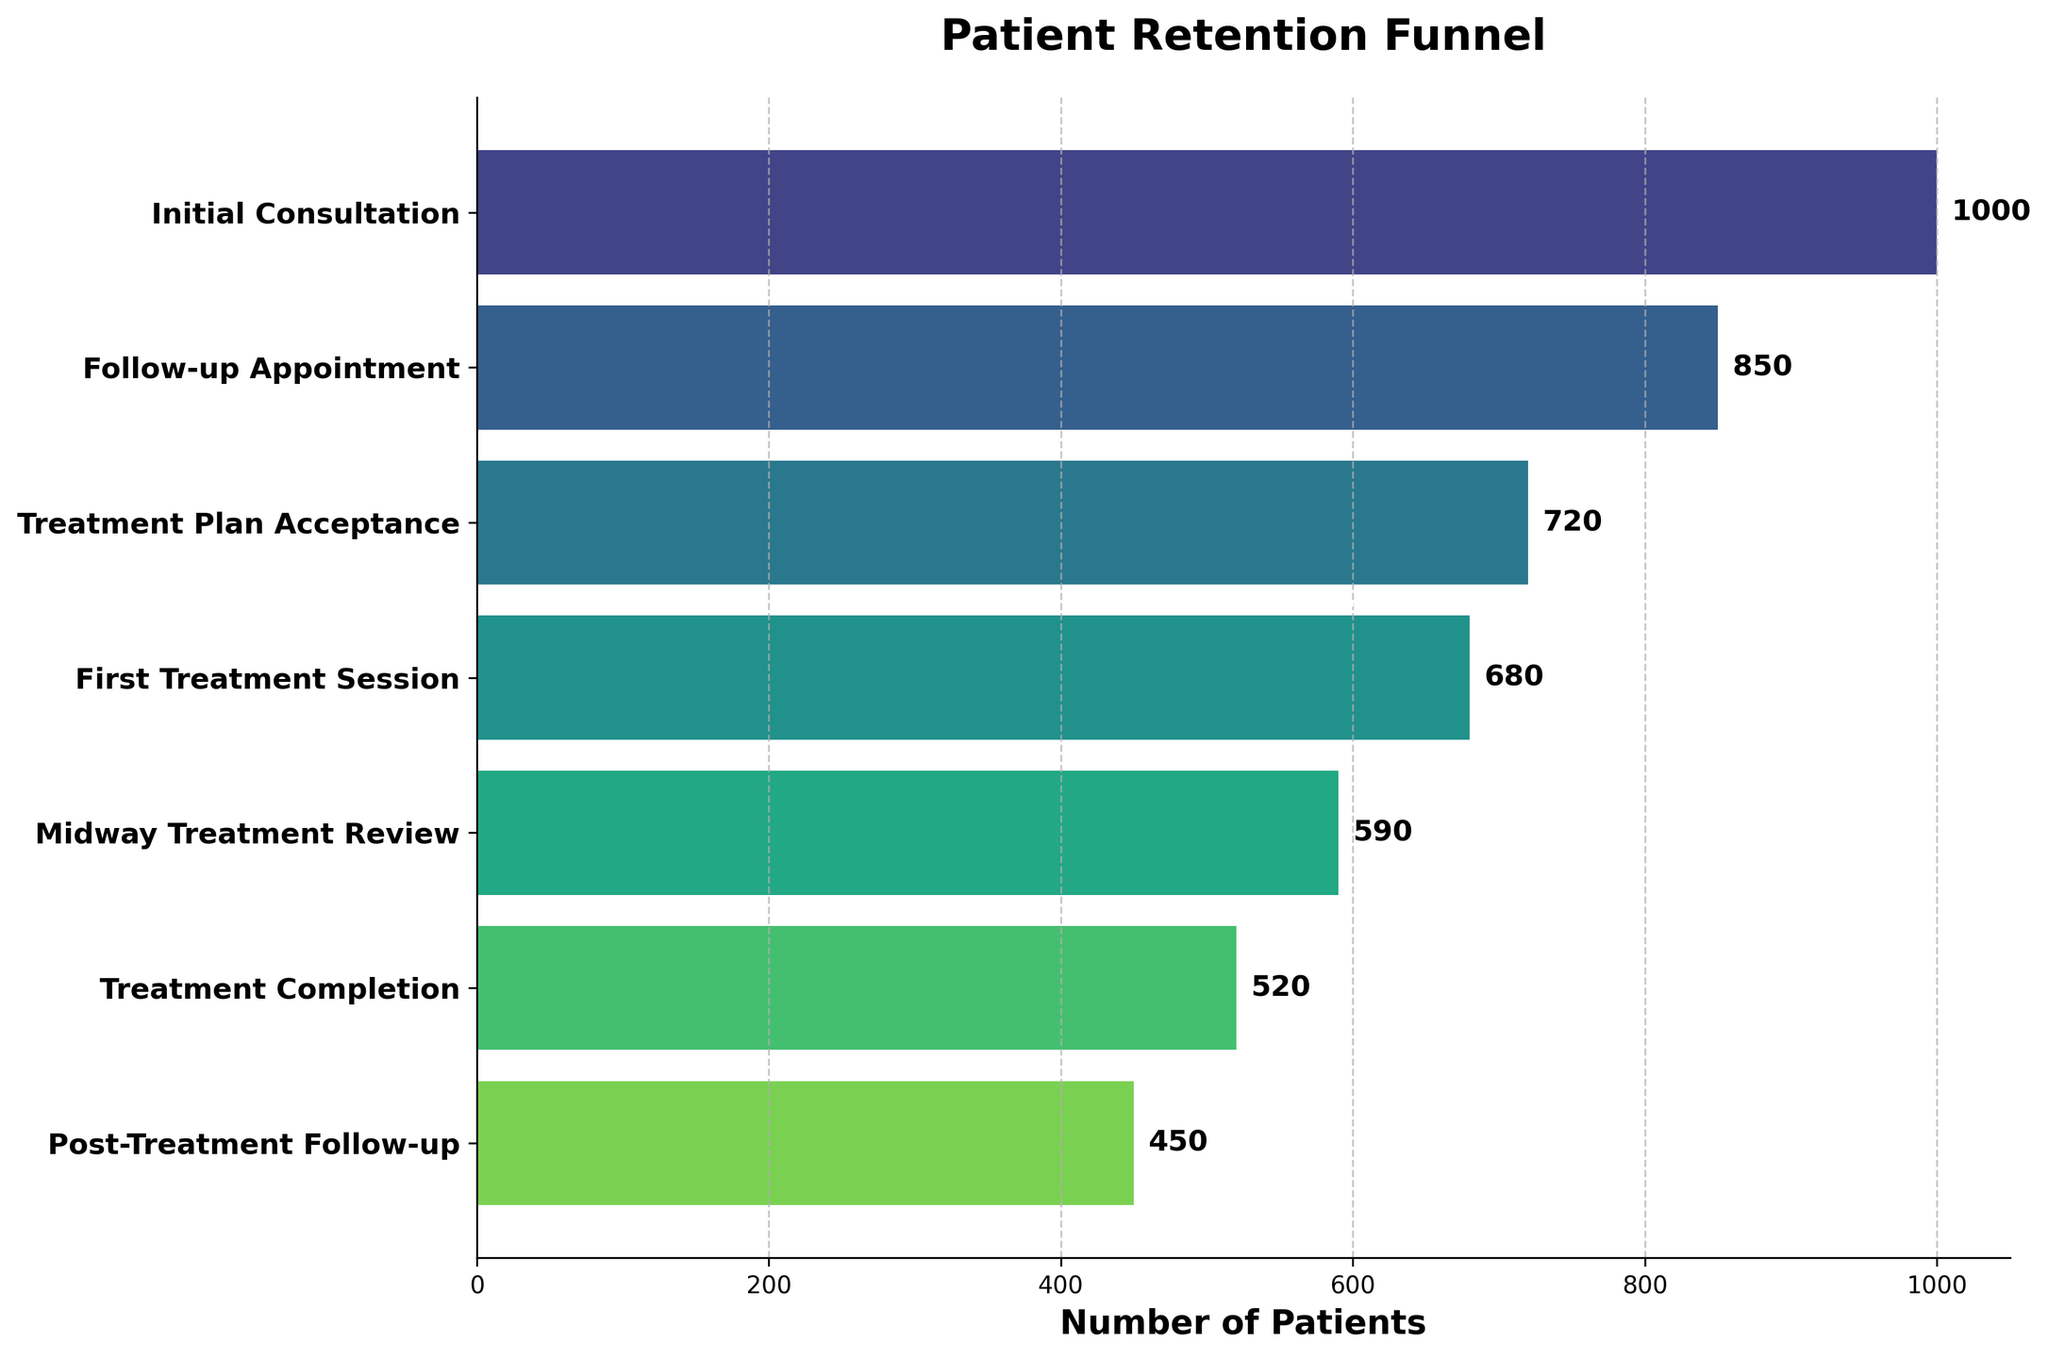What is the title of the chart? The title is written above the chart and summarizes the contents of the chart.
Answer: Patient Retention Funnel How many stages are there in the funnel? Count the number of stages listed on the Y-axis of the chart.
Answer: 7 At which stage is patient dropout the highest? Identify the stage with the largest difference in the number of patients compared to the previous stage.
Answer: Follow-up Appointment to Treatment Plan Acceptance How many patients completed the first treatment session? Read the number next to "First Treatment Session" on the horizontal bars.
Answer: 680 What percentage of patients moved from the initial consultation to the post-treatment follow-up? Calculate the percentage by dividing the number of patients at the post-treatment follow-up by the initial consultation and multiplying by 100. (450 / 1000) * 100 = 45%
Answer: 45% What is the difference in patient numbers between the follow-up appointment and the treatment plan acceptance stages? Subtract the number of patients in the treatment plan acceptance from the number in the follow-up appointment stage. 850 - 720 = 130
Answer: 130 Which stage has the lowest patient retention, and what is the retention percentage? Identify the stage with the smallest number of patients retained and calculate its percentage compared to the previous stage. The lowest retention is from the Follow-up Appointment to Treatment Plan Acceptance, (720 / 850) * 100 = 84.7%.
Answer: Treatment Plan Acceptance, 84.7% What is the total number of patients who dropped out from the initial consultation to the treatment completion stage? Subtract the number of patients at the treatment completion from the initial consultation. 1000 - 520 = 480
Answer: 480 What percentage of patients attended the midway treatment review after the first treatment session? Calculate the percentage by dividing the number of patients at the midway treatment review by those who attended the first treatment session and multiplying by 100. (590 / 680) * 100 = 86.8%
Answer: 86.8% Which stage retained more patients, the treatment plan acceptance stage or the post-treatment follow-up stage? Compare the number of patients at the treatment plan acceptance stage to those at the post-treatment follow-up stage. 720 > 450
Answer: Treatment Plan Acceptance 